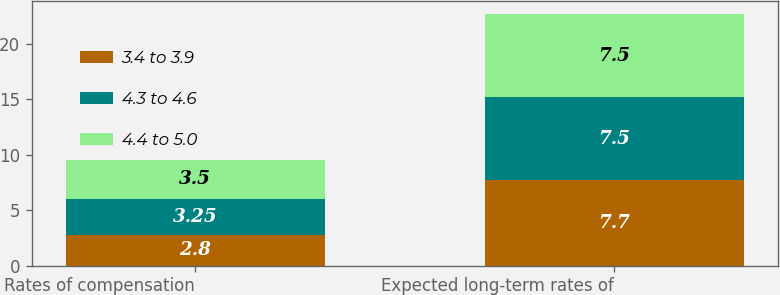<chart> <loc_0><loc_0><loc_500><loc_500><stacked_bar_chart><ecel><fcel>Rates of compensation<fcel>Expected long-term rates of<nl><fcel>3.4 to 3.9<fcel>2.8<fcel>7.7<nl><fcel>4.3 to 4.6<fcel>3.25<fcel>7.5<nl><fcel>4.4 to 5.0<fcel>3.5<fcel>7.5<nl></chart> 